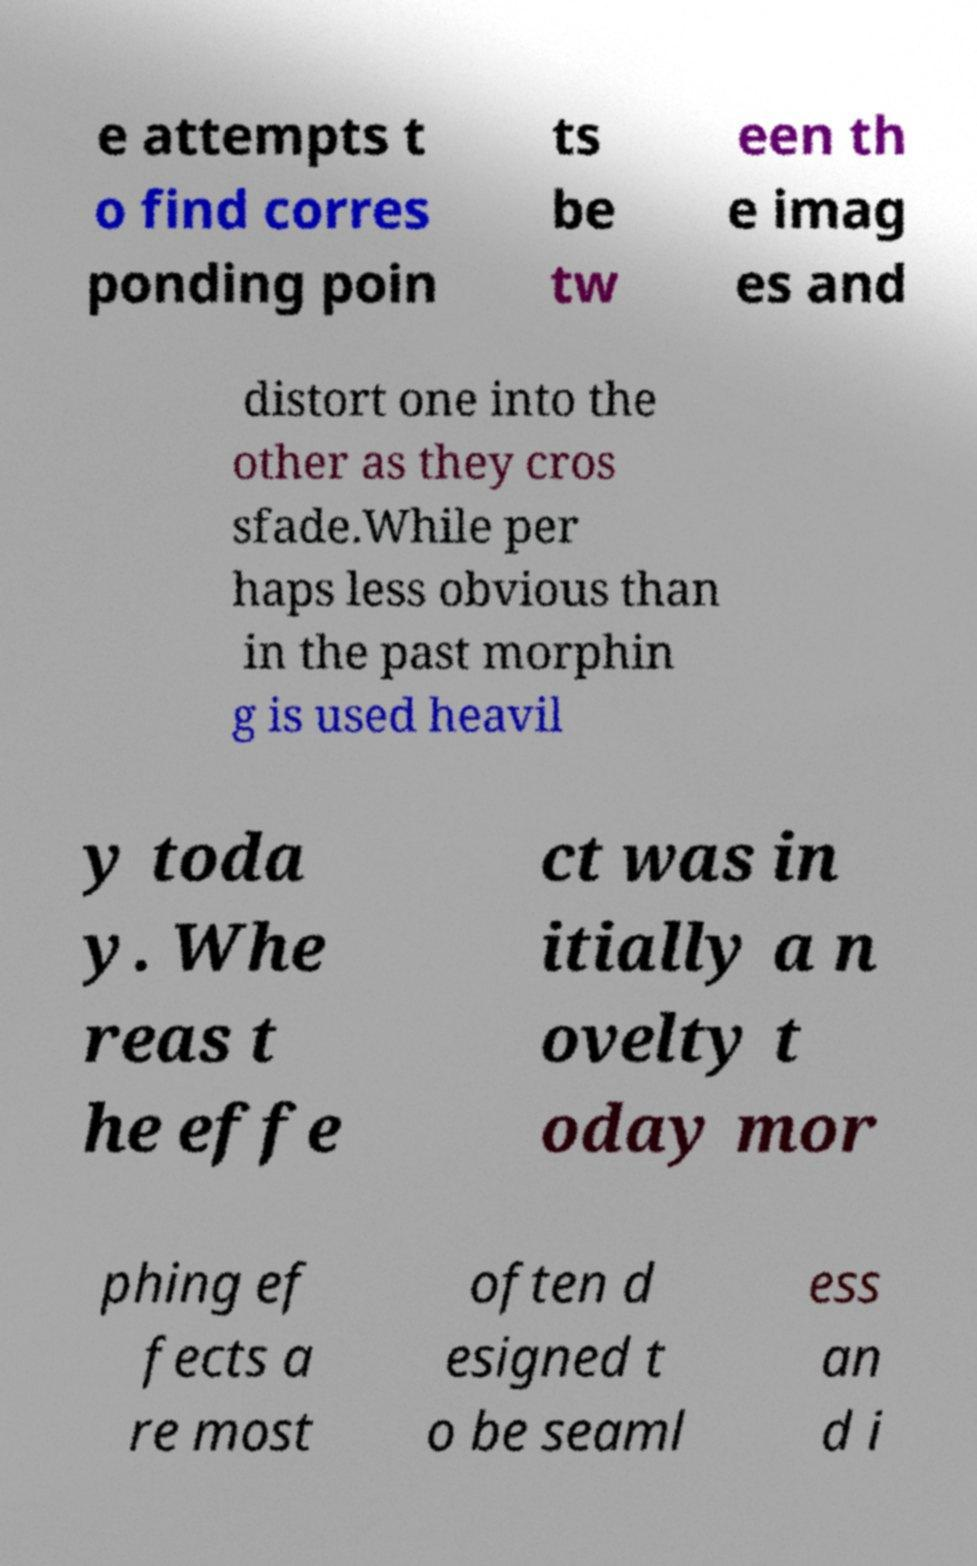Could you extract and type out the text from this image? e attempts t o find corres ponding poin ts be tw een th e imag es and distort one into the other as they cros sfade.While per haps less obvious than in the past morphin g is used heavil y toda y. Whe reas t he effe ct was in itially a n ovelty t oday mor phing ef fects a re most often d esigned t o be seaml ess an d i 